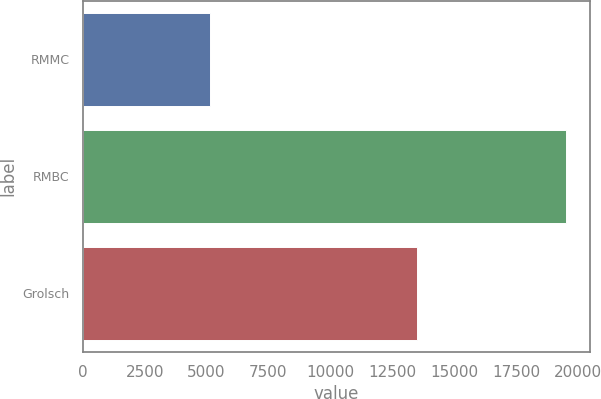<chart> <loc_0><loc_0><loc_500><loc_500><bar_chart><fcel>RMMC<fcel>RMBC<fcel>Grolsch<nl><fcel>5156<fcel>19507<fcel>13495<nl></chart> 